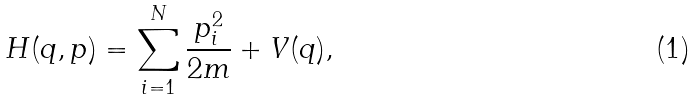Convert formula to latex. <formula><loc_0><loc_0><loc_500><loc_500>H ( q , p ) = \sum _ { i = 1 } ^ { N } \frac { p _ { i } ^ { 2 } } { 2 m } + V ( q ) ,</formula> 